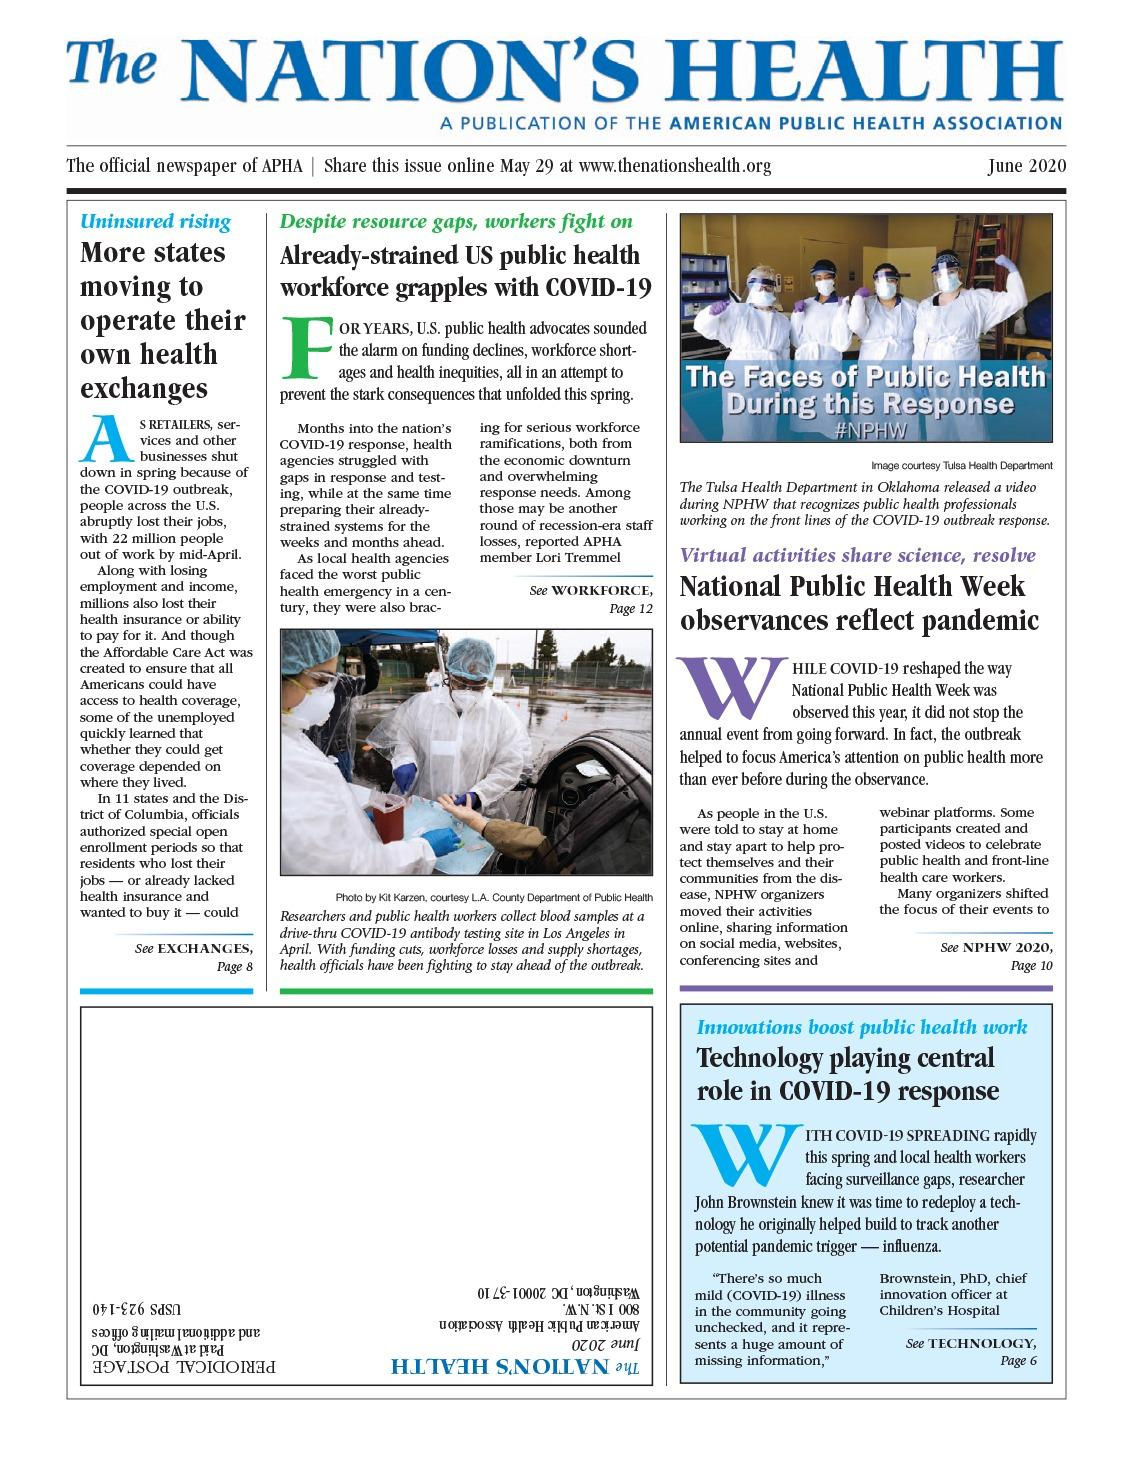Draw attention to some important aspects in this diagram. As of mid-April, approximately 22 million people across the United States were out of work. Due to the pandemic situation, the observance of National Public Health Week was shifted online. The photo at the top of the infographic shows 4 people. The color of the protective covering worn by all health workers in the photos is white. The Affordable Care Act was created with the goal of providing access to health coverage for all Americans. 